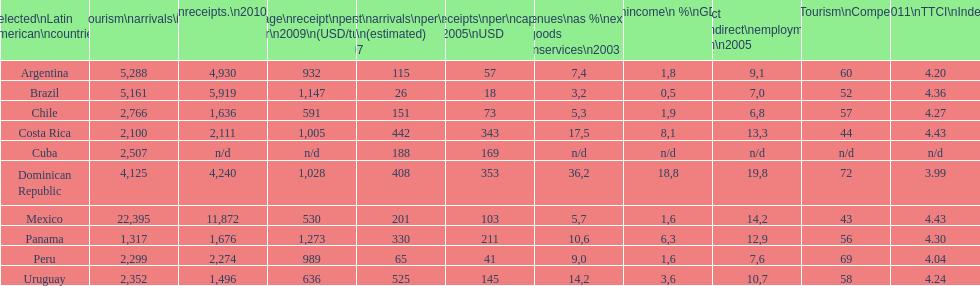Can you parse all the data within this table? {'header': ['Selected\\nLatin American\\ncountries', 'Internl.\\ntourism\\narrivals\\n2010\\n(x 1000)', 'Internl.\\ntourism\\nreceipts.\\n2010\\n(USD\\n(x1000)', 'Average\\nreceipt\\nper visitor\\n2009\\n(USD/turista)', 'Tourist\\narrivals\\nper\\n1000 inhab\\n(estimated) \\n2007', 'Receipts\\nper\\ncapita \\n2005\\nUSD', 'Revenues\\nas\xa0%\\nexports of\\ngoods and\\nservices\\n2003', 'Tourism\\nincome\\n\xa0%\\nGDP\\n2003', '% Direct and\\nindirect\\nemployment\\nin tourism\\n2005', 'World\\nranking\\nTourism\\nCompetitiv.\\nTTCI\\n2011', '2011\\nTTCI\\nIndex'], 'rows': [['Argentina', '5,288', '4,930', '932', '115', '57', '7,4', '1,8', '9,1', '60', '4.20'], ['Brazil', '5,161', '5,919', '1,147', '26', '18', '3,2', '0,5', '7,0', '52', '4.36'], ['Chile', '2,766', '1,636', '591', '151', '73', '5,3', '1,9', '6,8', '57', '4.27'], ['Costa Rica', '2,100', '2,111', '1,005', '442', '343', '17,5', '8,1', '13,3', '44', '4.43'], ['Cuba', '2,507', 'n/d', 'n/d', '188', '169', 'n/d', 'n/d', 'n/d', 'n/d', 'n/d'], ['Dominican Republic', '4,125', '4,240', '1,028', '408', '353', '36,2', '18,8', '19,8', '72', '3.99'], ['Mexico', '22,395', '11,872', '530', '201', '103', '5,7', '1,6', '14,2', '43', '4.43'], ['Panama', '1,317', '1,676', '1,273', '330', '211', '10,6', '6,3', '12,9', '56', '4.30'], ['Peru', '2,299', '2,274', '989', '65', '41', '9,0', '1,6', '7,6', '69', '4.04'], ['Uruguay', '2,352', '1,496', '636', '525', '145', '14,2', '3,6', '10,7', '58', '4.24']]} During 2003, up to what percentage of gdp did tourism income account for in latin american countries? 18,8. 